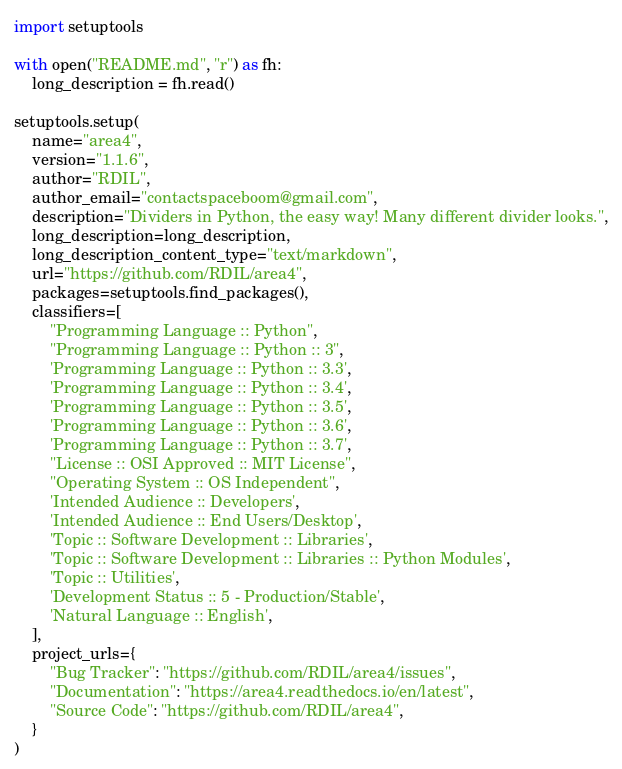Convert code to text. <code><loc_0><loc_0><loc_500><loc_500><_Python_>import setuptools

with open("README.md", "r") as fh:
    long_description = fh.read()

setuptools.setup(
    name="area4",
    version="1.1.6",
    author="RDIL",
    author_email="contactspaceboom@gmail.com",
    description="Dividers in Python, the easy way! Many different divider looks.",
    long_description=long_description,
    long_description_content_type="text/markdown",
    url="https://github.com/RDIL/area4",
    packages=setuptools.find_packages(),
    classifiers=[
        "Programming Language :: Python",
        "Programming Language :: Python :: 3",
        'Programming Language :: Python :: 3.3',
        'Programming Language :: Python :: 3.4',
        'Programming Language :: Python :: 3.5',
        'Programming Language :: Python :: 3.6',
        'Programming Language :: Python :: 3.7',
        "License :: OSI Approved :: MIT License",
        "Operating System :: OS Independent",
        'Intended Audience :: Developers',
        'Intended Audience :: End Users/Desktop',
        'Topic :: Software Development :: Libraries',
        'Topic :: Software Development :: Libraries :: Python Modules',
        'Topic :: Utilities',
        'Development Status :: 5 - Production/Stable',
        'Natural Language :: English',
    ],
    project_urls={
        "Bug Tracker": "https://github.com/RDIL/area4/issues",
        "Documentation": "https://area4.readthedocs.io/en/latest",
        "Source Code": "https://github.com/RDIL/area4",
    }
)
</code> 